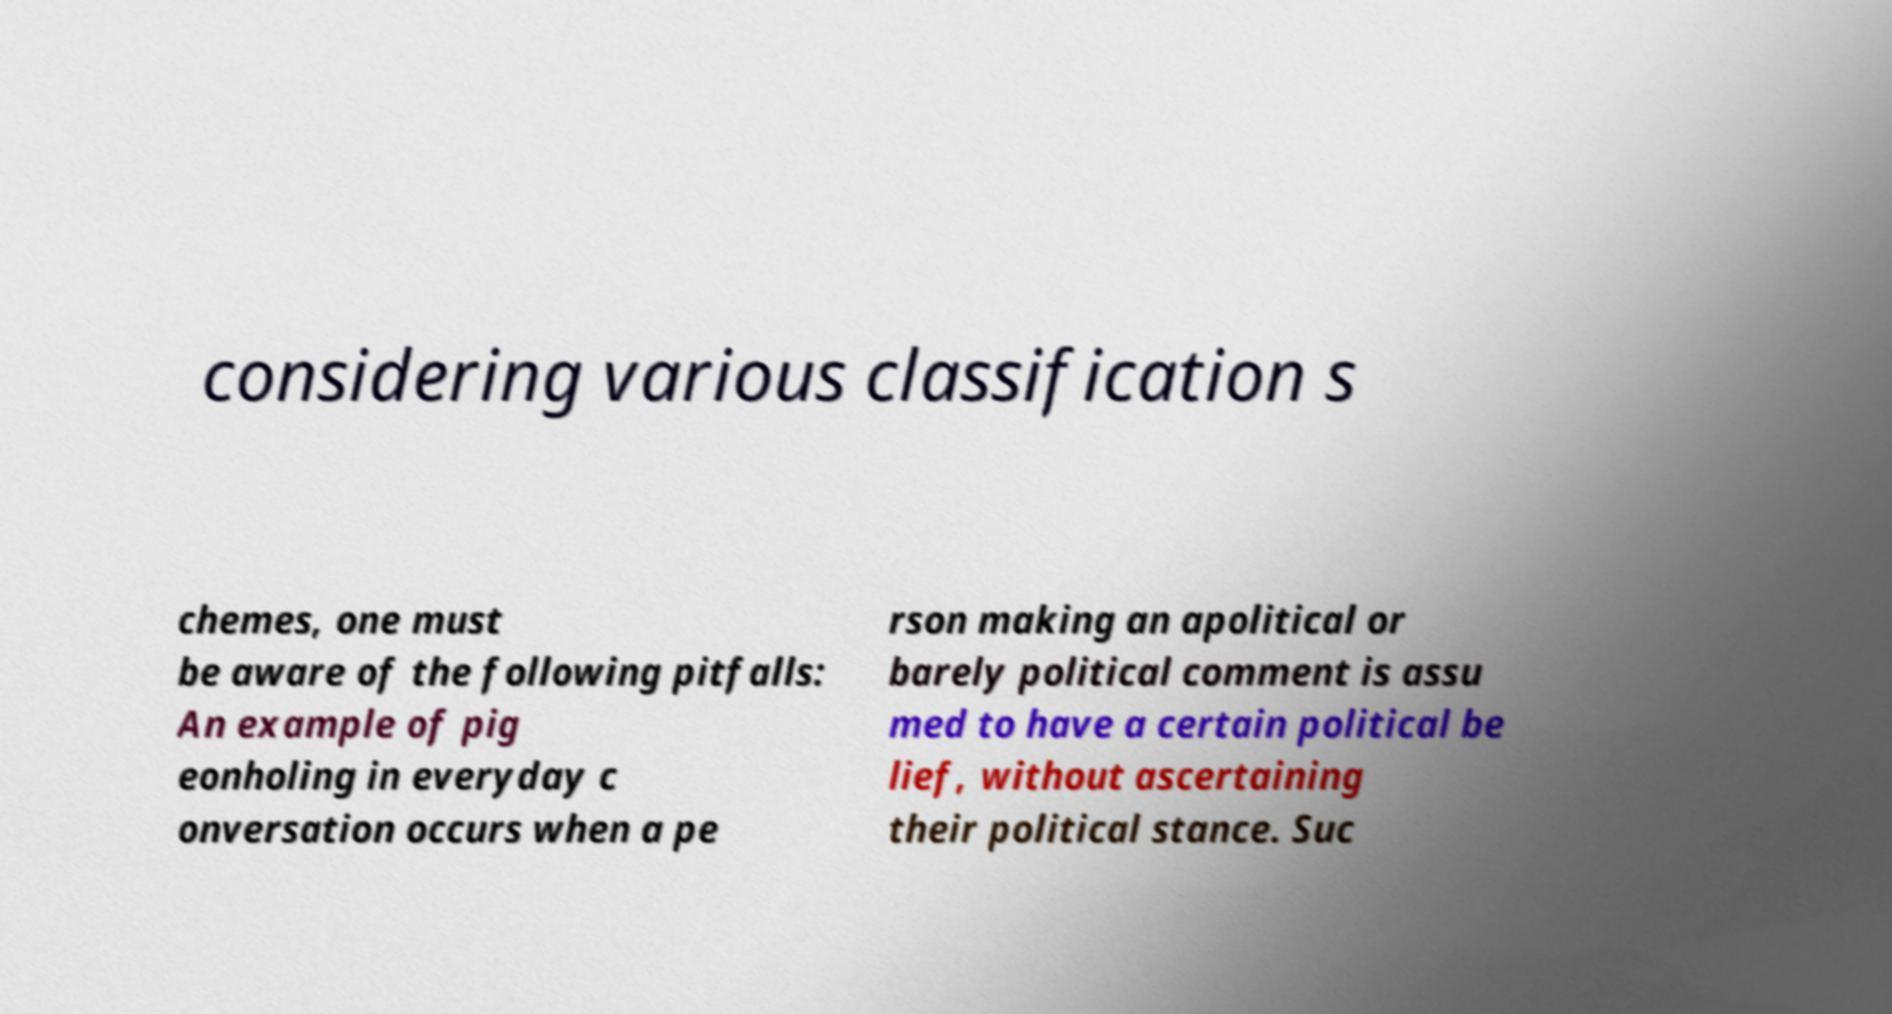Please identify and transcribe the text found in this image. considering various classification s chemes, one must be aware of the following pitfalls: An example of pig eonholing in everyday c onversation occurs when a pe rson making an apolitical or barely political comment is assu med to have a certain political be lief, without ascertaining their political stance. Suc 